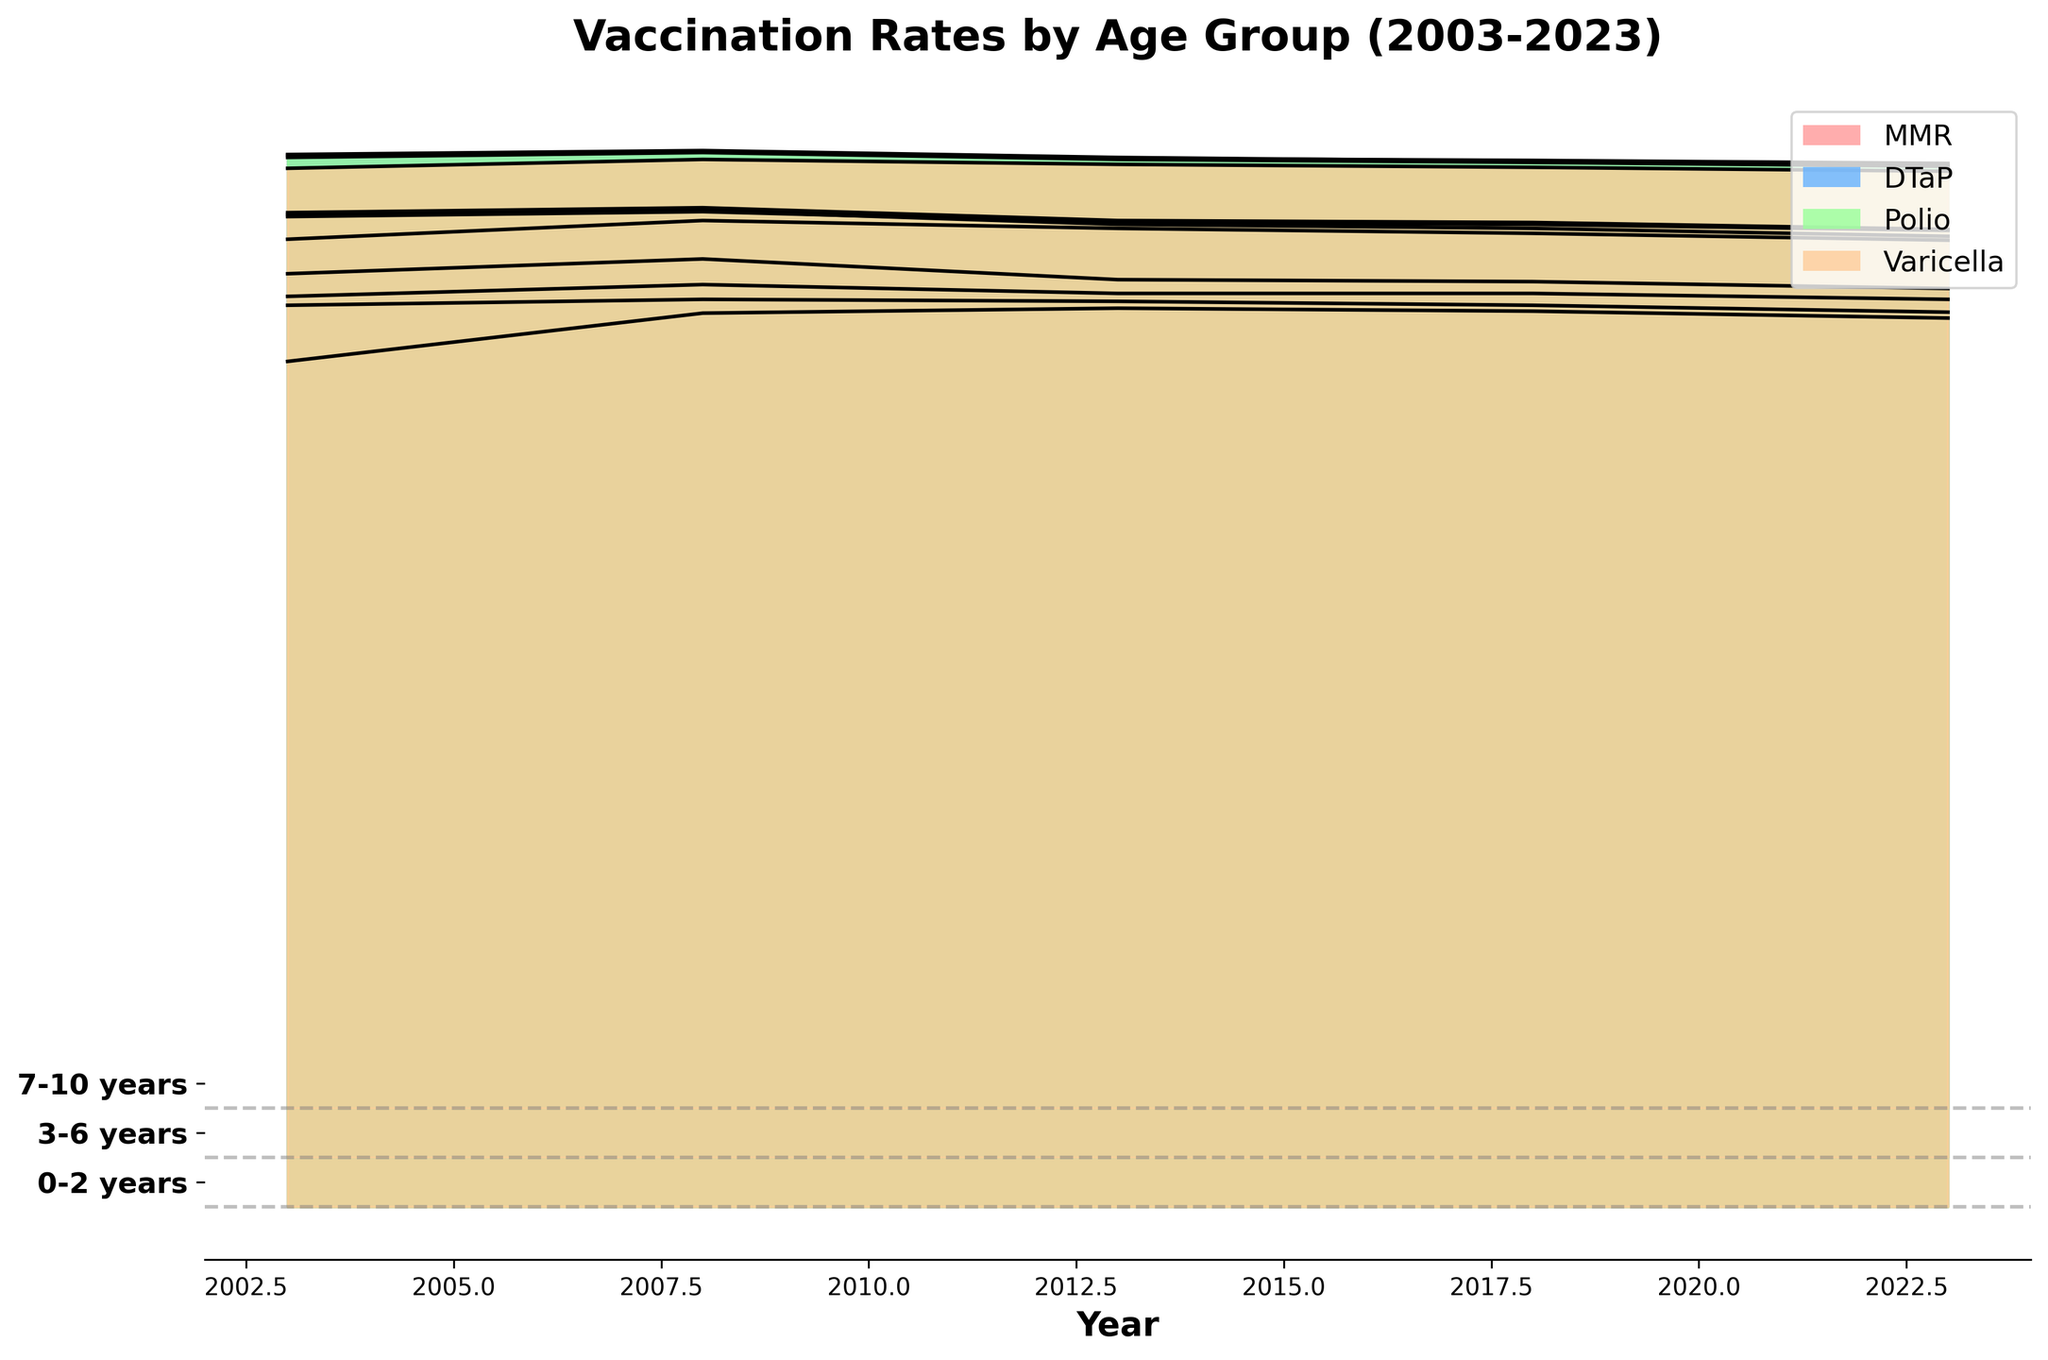How many age groups are displayed in the plot? Count the number of different age groups in the y-axis labels, which are provided on the plot.
Answer: 3 What year shows the highest vaccination rate for the Polio vaccine in the 7-10 years age group? Look for the peak point in the Polio vaccination curve for the 7-10 years group within the plot.
Answer: 2008 How has the MMR vaccination rate for the 0-2 years age group changed from 2003 to 2023? Observe the MMR vaccination curve for the 0-2 years age group and compare the start (2003) and end (2023) values.
Answer: Decreased Which vaccine had the highest rate in 2013 for the 3-6 years age group? Identify the vaccine curve that reaches the highest value in the year 2013 for the 3-6 years age group in the plot.
Answer: DTaP What is the trend of Varicella vaccination rates in the 0-2 years age group over the years? Examine the Varicella vaccination curve for the 0-2 years age group and note the changes from the earliest to the latest year.
Answer: Increasing Between the Age Groups 3-6 years and 7-10 years, which one had higher MMR rates in 2018? Compare the MMR vaccination values for both age groups in the year 2018 on the plot.
Answer: 7-10 years What is the overall trend for DTaP vaccination rates across all age groups over the last 20 years? Look at the DTaP vaccination curves for each age group and summarize the general pattern over the years.
Answer: Slightly decreasing Which age group shows the most stable trend over the years in terms of vaccination rates for all vaccines? Compare the consistency in vaccination rates of all vaccines across the different age groups in the plot.
Answer: 7-10 years What is the difference in the Varicella vaccination rates between the 7-10 years age group and the 0-2 years age group in 2023? Subtract the Varicella vaccination rate of the 0-2 years age group from that of the 7-10 years age group in the year 2023.
Answer: 4.9% 